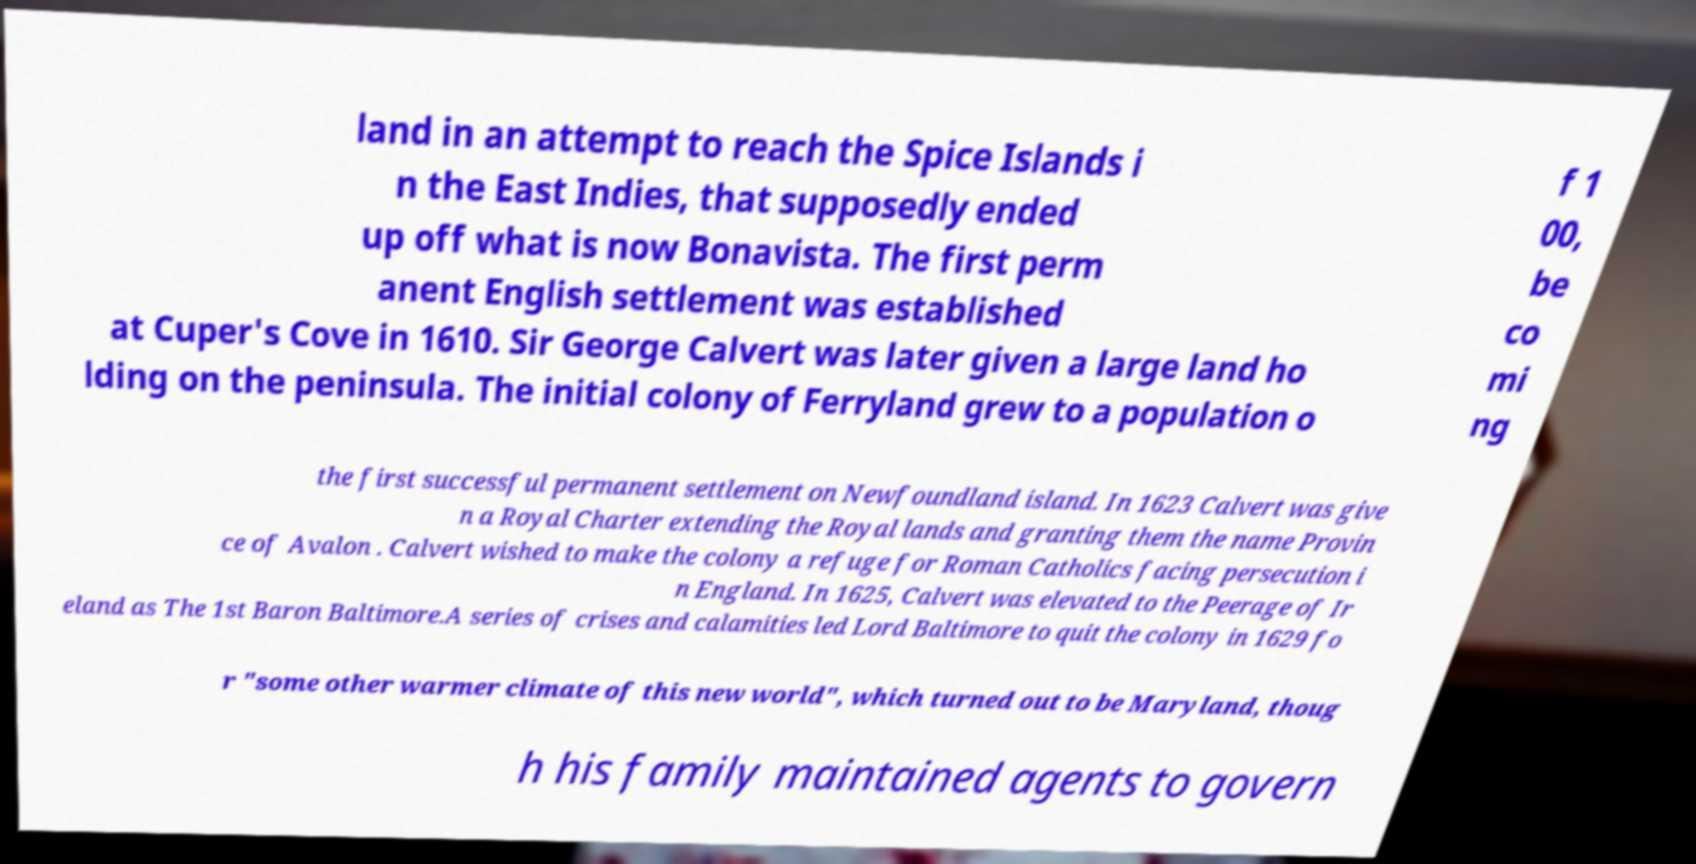Could you assist in decoding the text presented in this image and type it out clearly? land in an attempt to reach the Spice Islands i n the East Indies, that supposedly ended up off what is now Bonavista. The first perm anent English settlement was established at Cuper's Cove in 1610. Sir George Calvert was later given a large land ho lding on the peninsula. The initial colony of Ferryland grew to a population o f 1 00, be co mi ng the first successful permanent settlement on Newfoundland island. In 1623 Calvert was give n a Royal Charter extending the Royal lands and granting them the name Provin ce of Avalon . Calvert wished to make the colony a refuge for Roman Catholics facing persecution i n England. In 1625, Calvert was elevated to the Peerage of Ir eland as The 1st Baron Baltimore.A series of crises and calamities led Lord Baltimore to quit the colony in 1629 fo r "some other warmer climate of this new world", which turned out to be Maryland, thoug h his family maintained agents to govern 